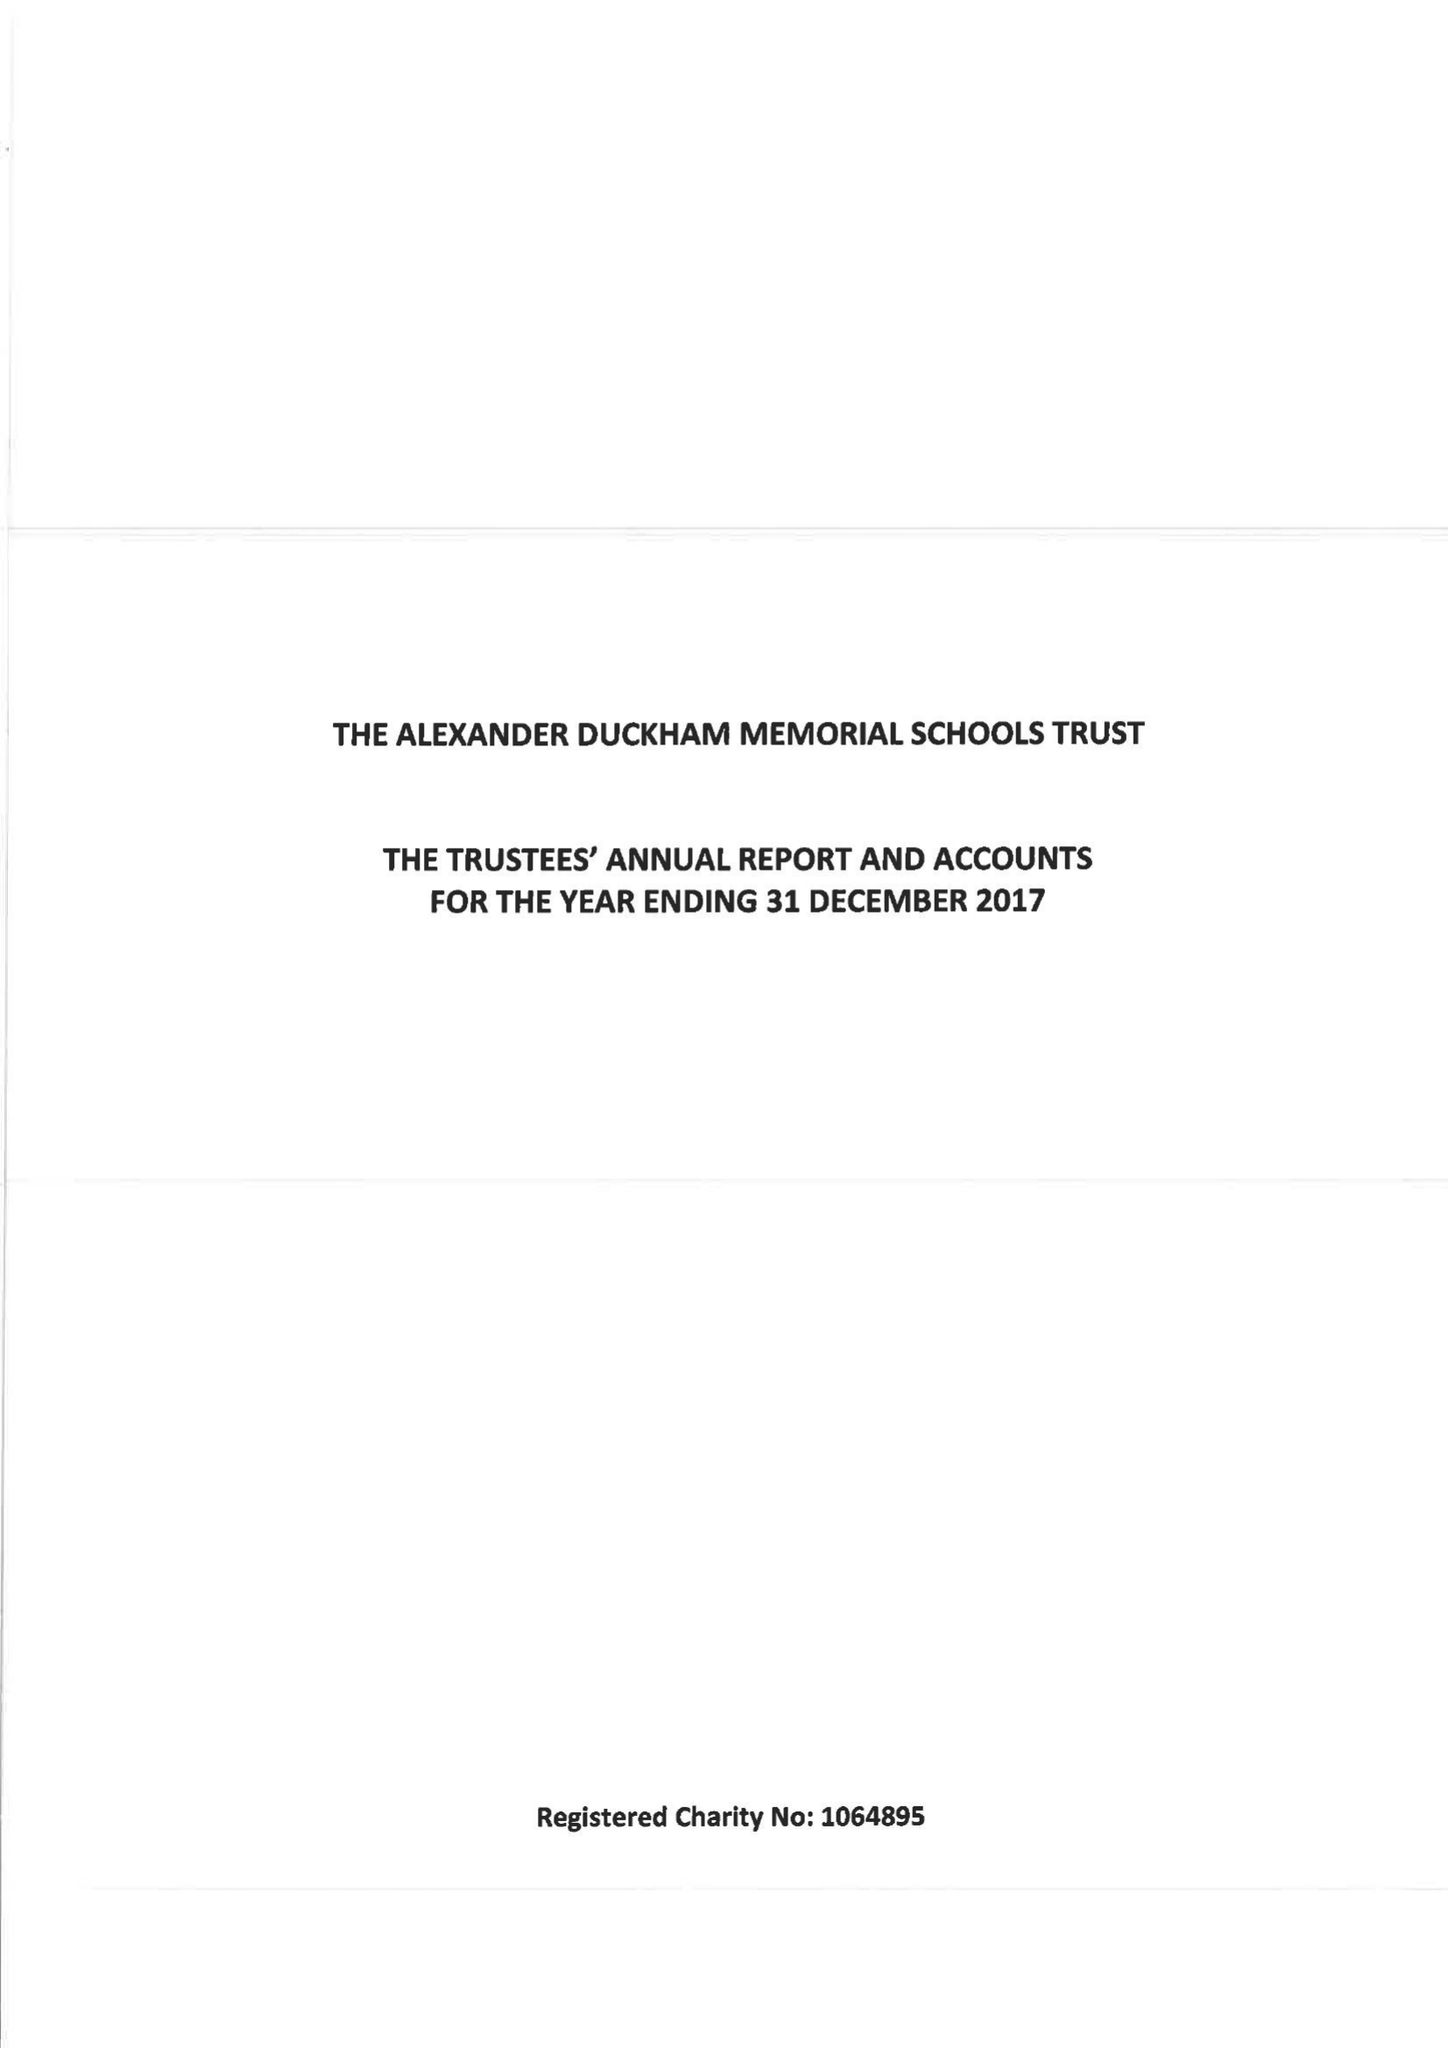What is the value for the report_date?
Answer the question using a single word or phrase. 2017-12-31 